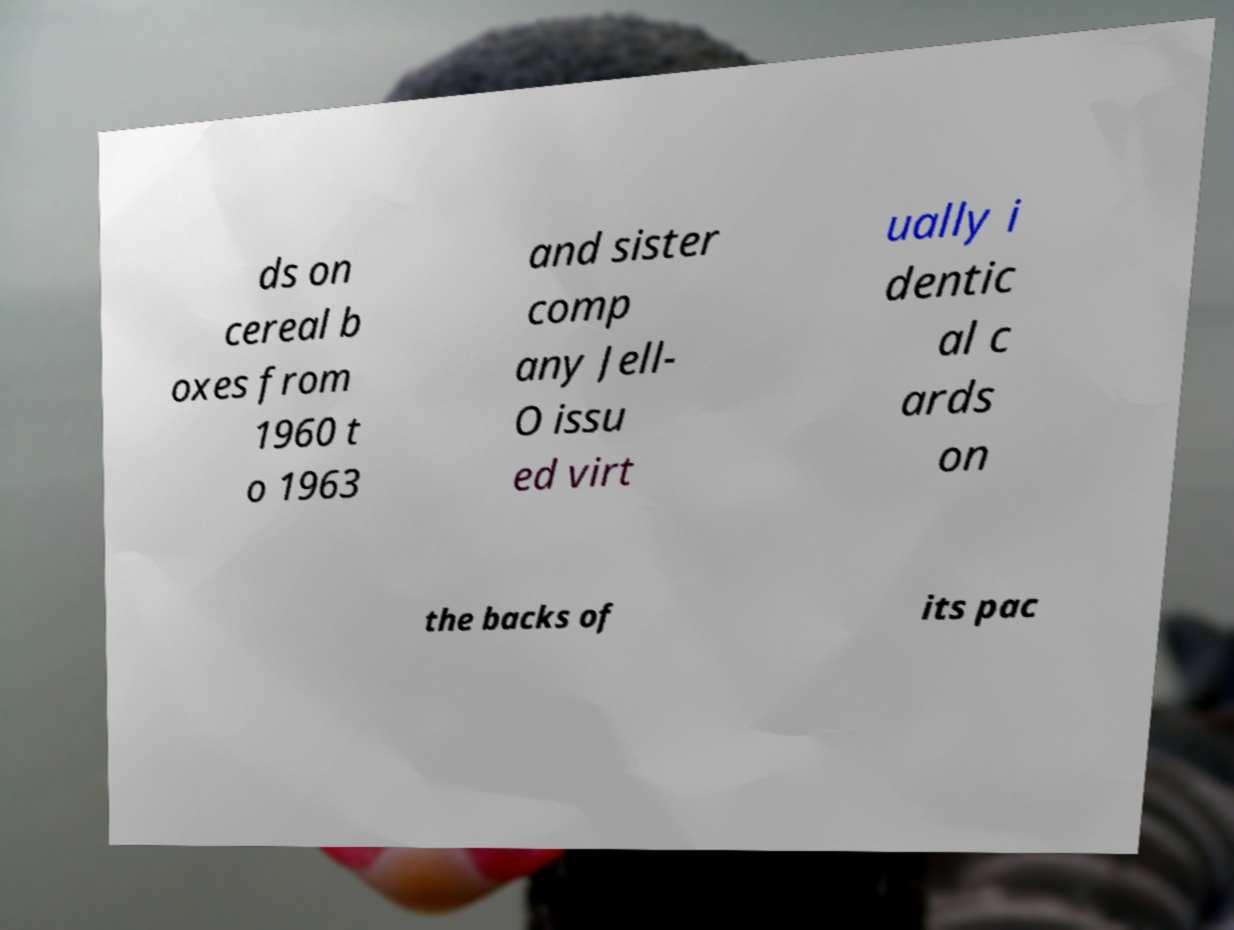Could you assist in decoding the text presented in this image and type it out clearly? ds on cereal b oxes from 1960 t o 1963 and sister comp any Jell- O issu ed virt ually i dentic al c ards on the backs of its pac 